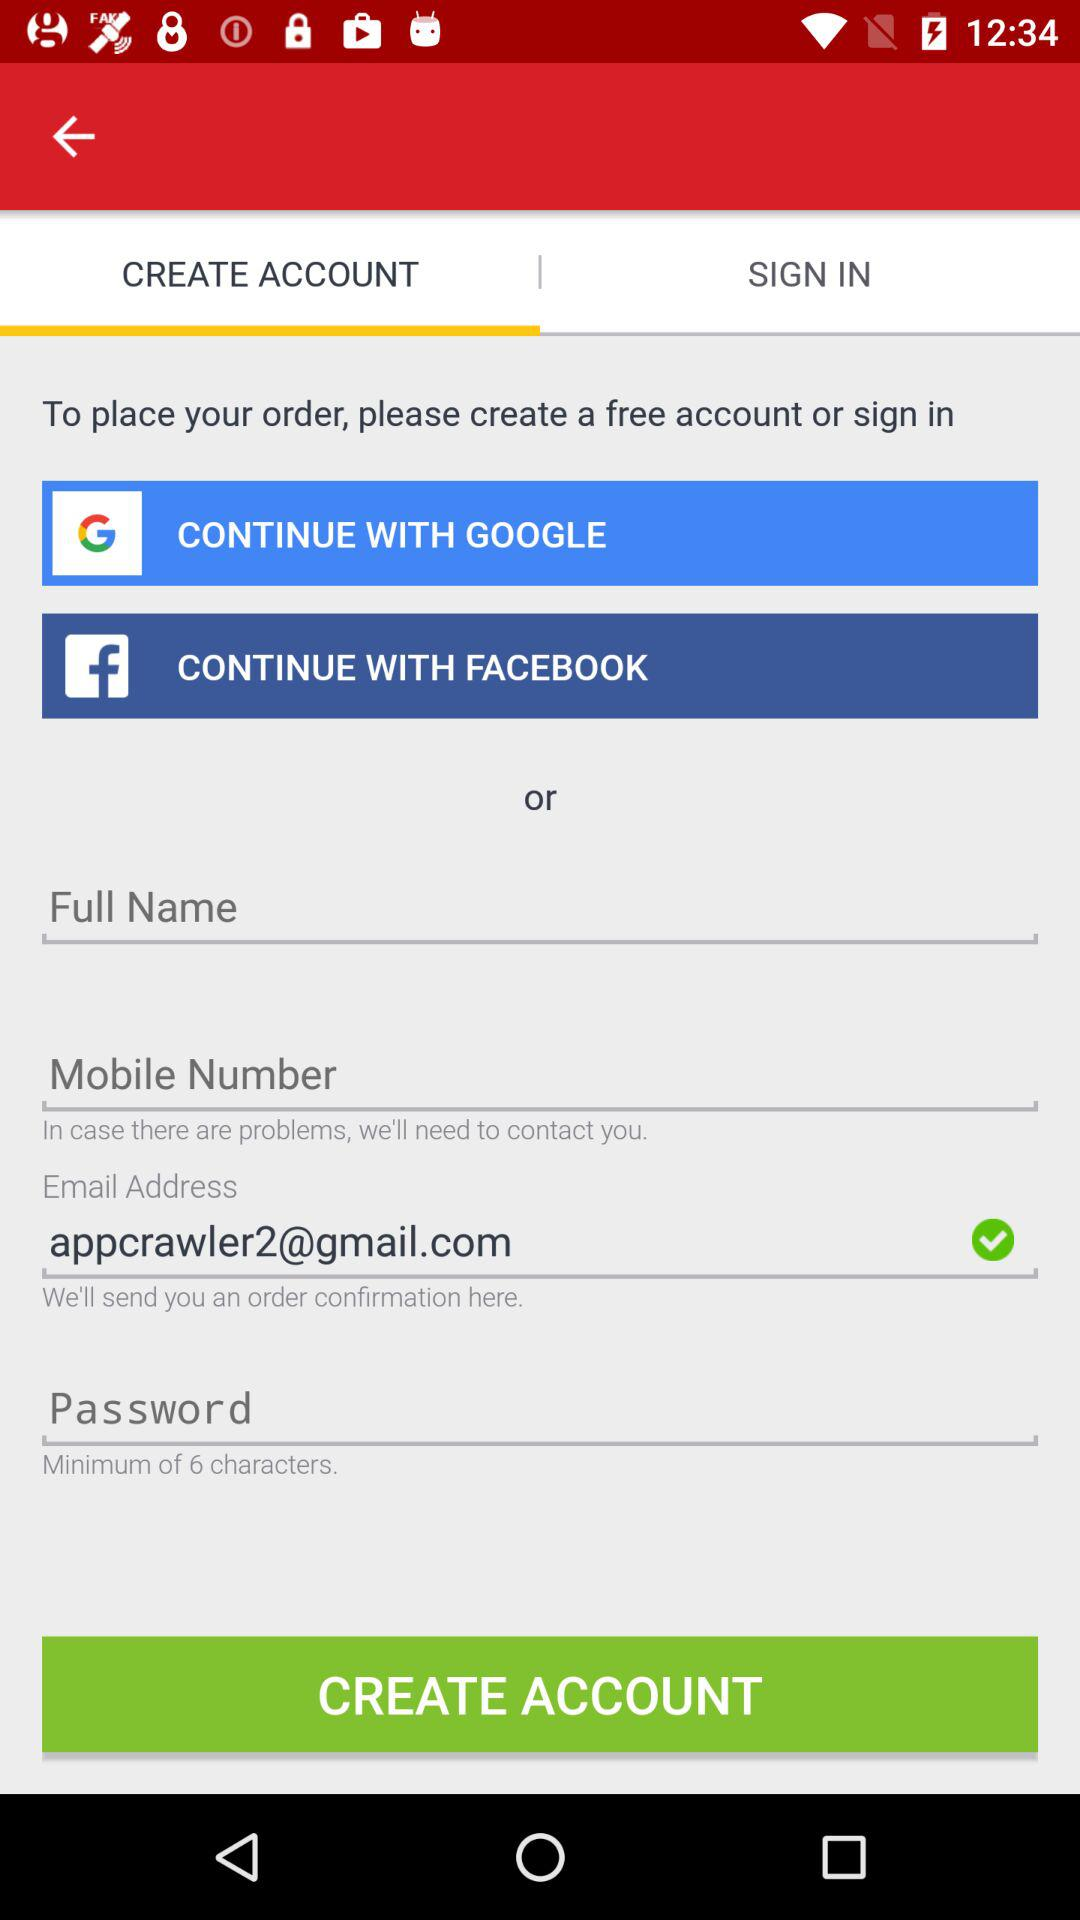What are the minimum characters required for the password? The minimum characters required for the password are 6. 